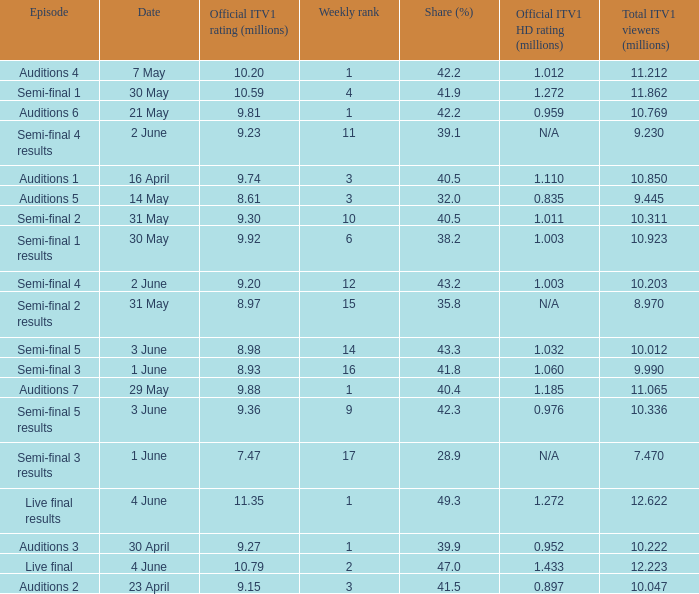When was the episode that had a share (%) of 41.5? 23 April. 